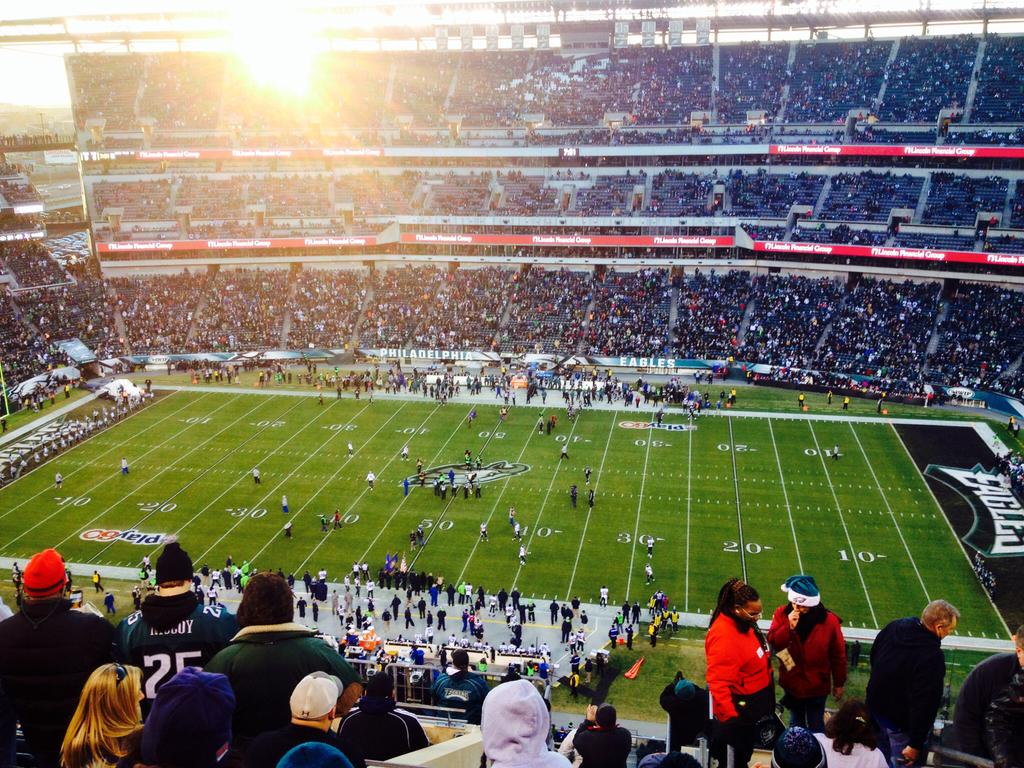How many people are in the image? There are people in the image, but the exact number is not specified. Can you describe the distribution of the people in the image? The people are scattered throughout the image. What type of terrain is visible in the image? There is grass in the image. Are there any architectural features present in the image? Yes, there are stairs in the image. What is the source of illumination in the image? There is light in the image. What type of wound can be seen on the cast in the image? There is no cast or wound present in the image. How many screws are visible in the image? There are no screws visible in the image. 